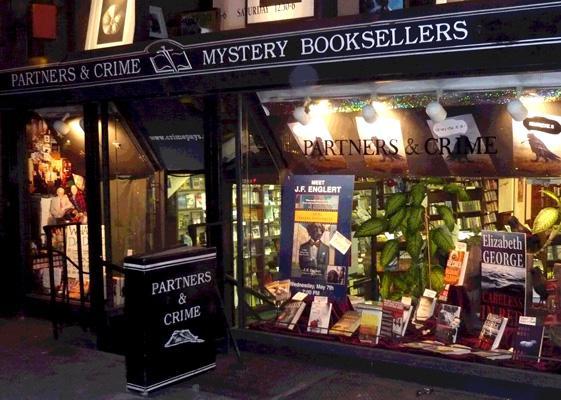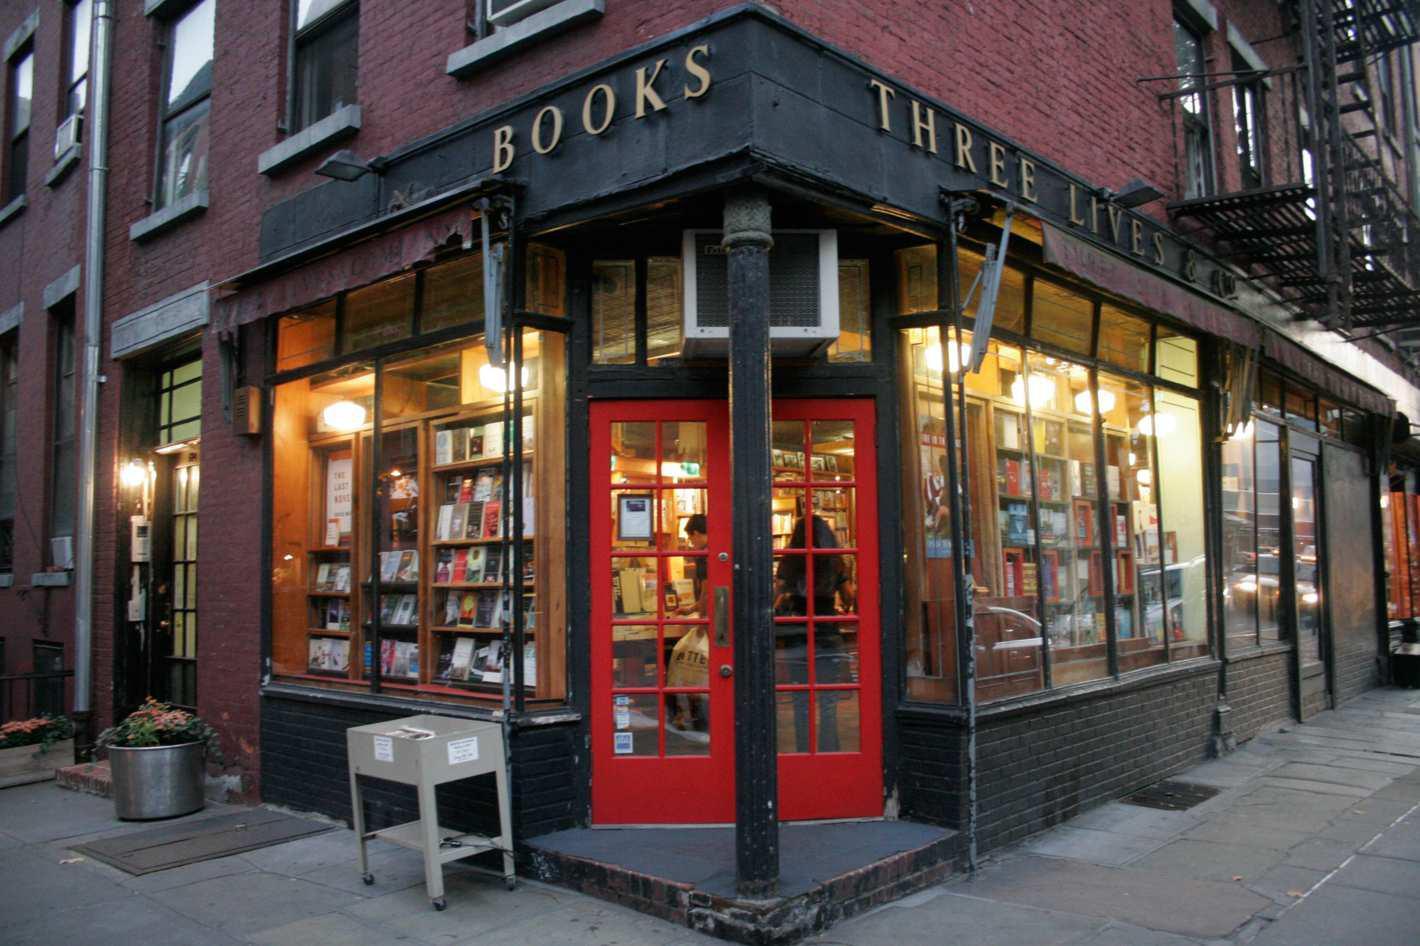The first image is the image on the left, the second image is the image on the right. Considering the images on both sides, is "The door in the right image is open." valid? Answer yes or no. No. The first image is the image on the left, the second image is the image on the right. Assess this claim about the two images: "The right image shows a bookstore in the corner of a dark red brick building, with its name on black above a red door.". Correct or not? Answer yes or no. Yes. 